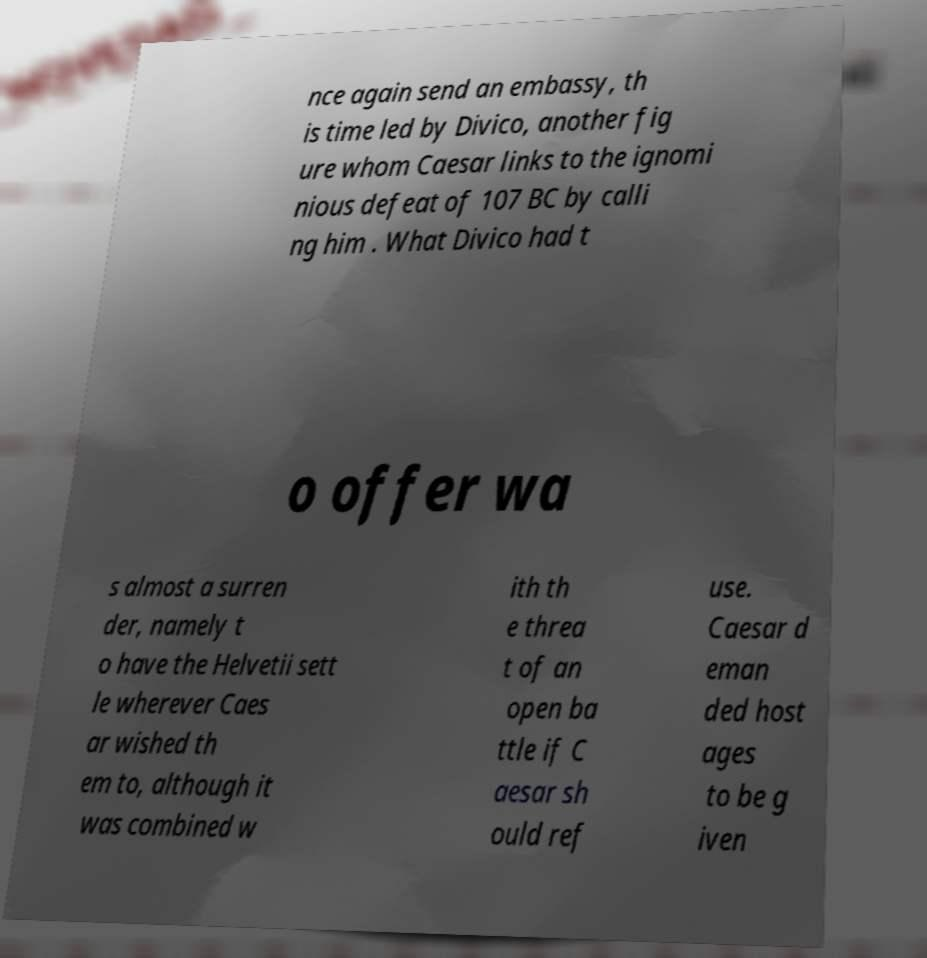Could you extract and type out the text from this image? nce again send an embassy, th is time led by Divico, another fig ure whom Caesar links to the ignomi nious defeat of 107 BC by calli ng him . What Divico had t o offer wa s almost a surren der, namely t o have the Helvetii sett le wherever Caes ar wished th em to, although it was combined w ith th e threa t of an open ba ttle if C aesar sh ould ref use. Caesar d eman ded host ages to be g iven 